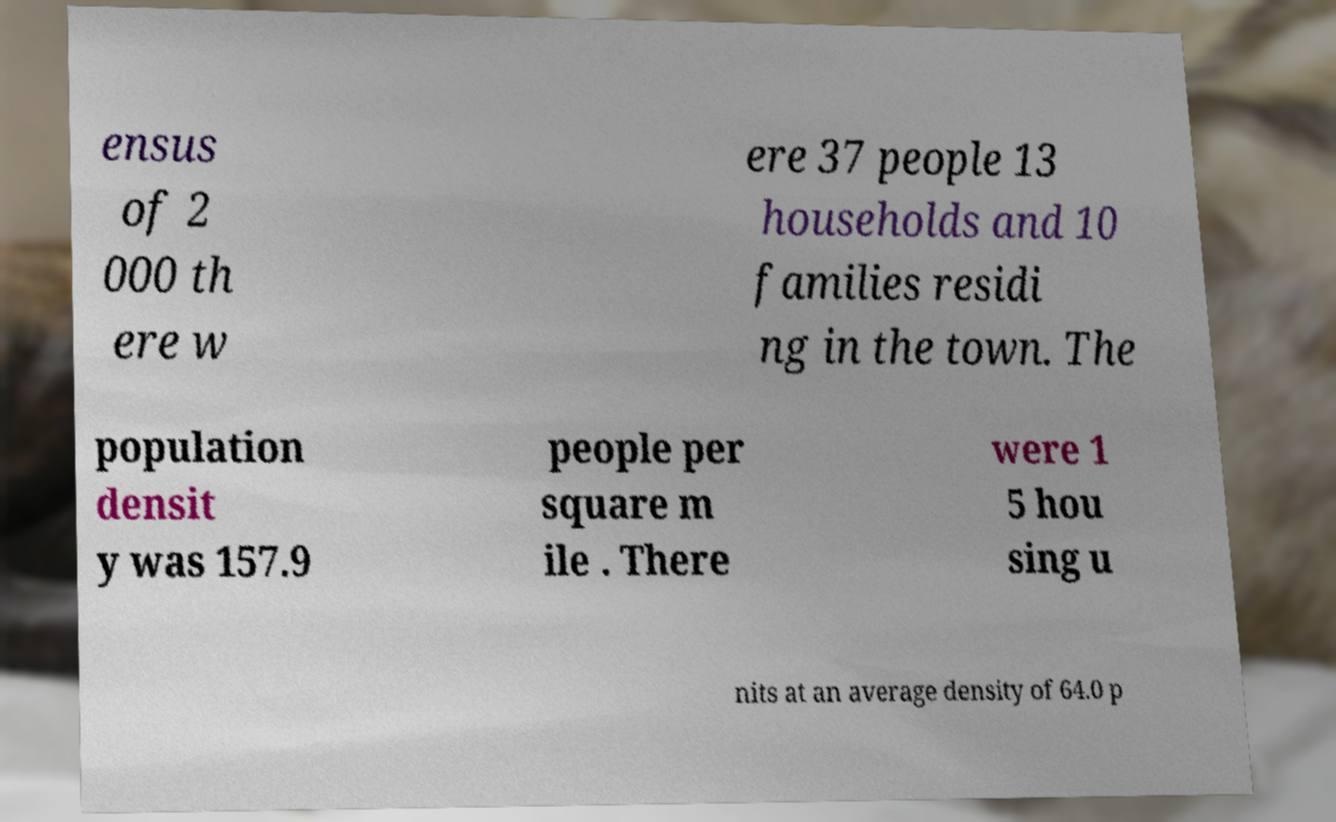What messages or text are displayed in this image? I need them in a readable, typed format. ensus of 2 000 th ere w ere 37 people 13 households and 10 families residi ng in the town. The population densit y was 157.9 people per square m ile . There were 1 5 hou sing u nits at an average density of 64.0 p 